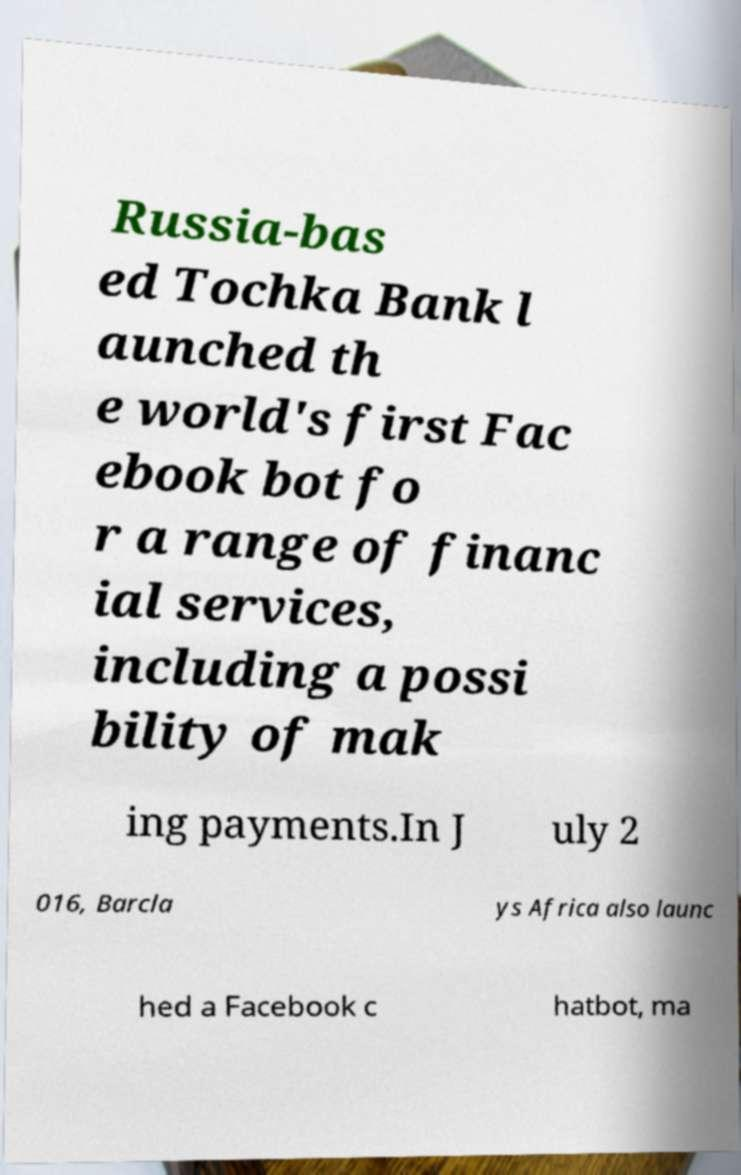Could you extract and type out the text from this image? Russia-bas ed Tochka Bank l aunched th e world's first Fac ebook bot fo r a range of financ ial services, including a possi bility of mak ing payments.In J uly 2 016, Barcla ys Africa also launc hed a Facebook c hatbot, ma 